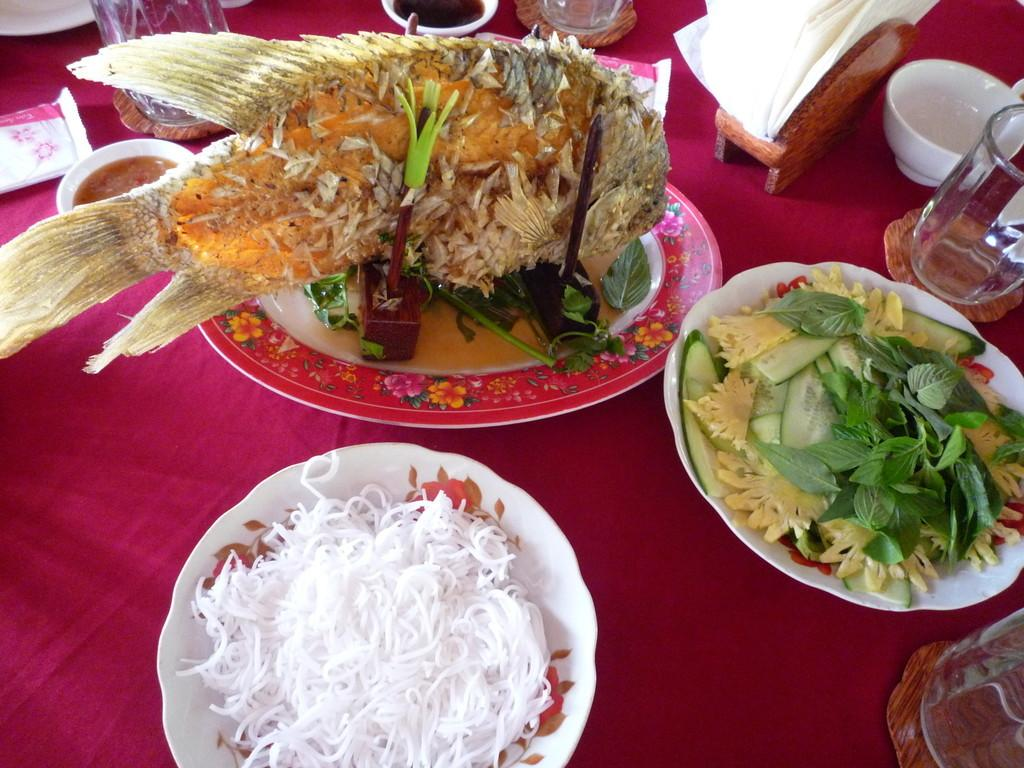What is present on the plates in the image? There are food items on plates in the image. What else can be seen on the cloth in the image? There are objects on the cloth in the image. How are the plates arranged in the image? The plates are placed on the cloth in the image. What is the square's role in the image? There is no square present in the image. 